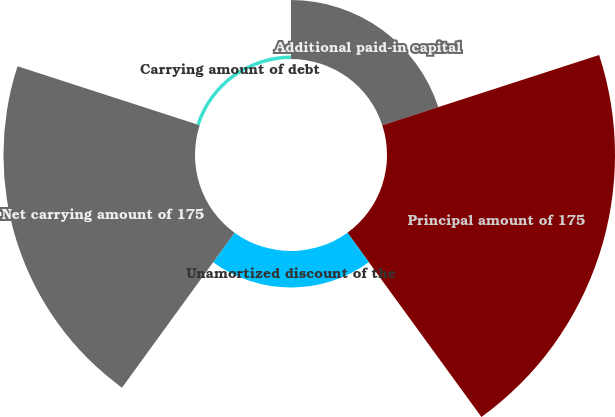Convert chart. <chart><loc_0><loc_0><loc_500><loc_500><pie_chart><fcel>Additional paid-in capital<fcel>Principal amount of 175<fcel>Unamortized discount of the<fcel>Net carrying amount of 175<fcel>Carrying amount of debt<nl><fcel>11.36%<fcel>43.98%<fcel>7.03%<fcel>36.95%<fcel>0.67%<nl></chart> 